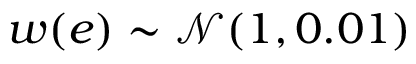<formula> <loc_0><loc_0><loc_500><loc_500>w ( e ) \sim \mathcal { N } ( 1 , 0 . 0 1 )</formula> 